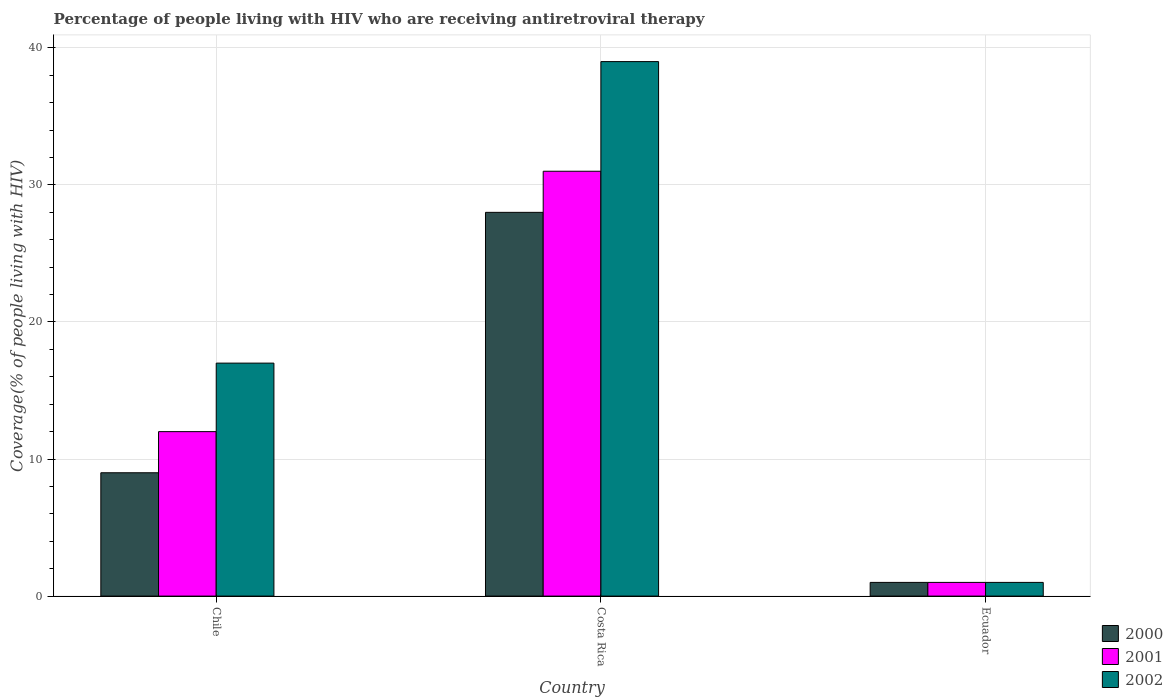How many different coloured bars are there?
Keep it short and to the point. 3. Are the number of bars on each tick of the X-axis equal?
Your answer should be compact. Yes. What is the label of the 3rd group of bars from the left?
Make the answer very short. Ecuador. In how many cases, is the number of bars for a given country not equal to the number of legend labels?
Provide a short and direct response. 0. Across all countries, what is the maximum percentage of the HIV infected people who are receiving antiretroviral therapy in 2000?
Ensure brevity in your answer.  28. Across all countries, what is the minimum percentage of the HIV infected people who are receiving antiretroviral therapy in 2002?
Provide a short and direct response. 1. In which country was the percentage of the HIV infected people who are receiving antiretroviral therapy in 2002 maximum?
Your response must be concise. Costa Rica. In which country was the percentage of the HIV infected people who are receiving antiretroviral therapy in 2000 minimum?
Ensure brevity in your answer.  Ecuador. What is the difference between the percentage of the HIV infected people who are receiving antiretroviral therapy in 2001 in Chile and the percentage of the HIV infected people who are receiving antiretroviral therapy in 2000 in Ecuador?
Make the answer very short. 11. What is the average percentage of the HIV infected people who are receiving antiretroviral therapy in 2000 per country?
Provide a short and direct response. 12.67. In how many countries, is the percentage of the HIV infected people who are receiving antiretroviral therapy in 2001 greater than 26 %?
Give a very brief answer. 1. What is the ratio of the percentage of the HIV infected people who are receiving antiretroviral therapy in 2000 in Chile to that in Costa Rica?
Your answer should be compact. 0.32. Is the difference between the percentage of the HIV infected people who are receiving antiretroviral therapy in 2002 in Chile and Costa Rica greater than the difference between the percentage of the HIV infected people who are receiving antiretroviral therapy in 2001 in Chile and Costa Rica?
Provide a succinct answer. No. What is the difference between the highest and the second highest percentage of the HIV infected people who are receiving antiretroviral therapy in 2001?
Give a very brief answer. -11. In how many countries, is the percentage of the HIV infected people who are receiving antiretroviral therapy in 2001 greater than the average percentage of the HIV infected people who are receiving antiretroviral therapy in 2001 taken over all countries?
Keep it short and to the point. 1. What does the 2nd bar from the right in Chile represents?
Your answer should be very brief. 2001. Does the graph contain any zero values?
Your answer should be compact. No. How many legend labels are there?
Ensure brevity in your answer.  3. How are the legend labels stacked?
Give a very brief answer. Vertical. What is the title of the graph?
Give a very brief answer. Percentage of people living with HIV who are receiving antiretroviral therapy. Does "2014" appear as one of the legend labels in the graph?
Your answer should be very brief. No. What is the label or title of the Y-axis?
Offer a very short reply. Coverage(% of people living with HIV). What is the Coverage(% of people living with HIV) of 2002 in Chile?
Your answer should be very brief. 17. What is the Coverage(% of people living with HIV) of 2000 in Costa Rica?
Offer a terse response. 28. What is the Coverage(% of people living with HIV) of 2000 in Ecuador?
Make the answer very short. 1. Across all countries, what is the minimum Coverage(% of people living with HIV) in 2001?
Make the answer very short. 1. Across all countries, what is the minimum Coverage(% of people living with HIV) in 2002?
Make the answer very short. 1. What is the total Coverage(% of people living with HIV) in 2000 in the graph?
Give a very brief answer. 38. What is the total Coverage(% of people living with HIV) of 2001 in the graph?
Ensure brevity in your answer.  44. What is the total Coverage(% of people living with HIV) in 2002 in the graph?
Offer a very short reply. 57. What is the difference between the Coverage(% of people living with HIV) in 2000 in Chile and that in Costa Rica?
Offer a very short reply. -19. What is the difference between the Coverage(% of people living with HIV) in 2001 in Chile and that in Costa Rica?
Give a very brief answer. -19. What is the difference between the Coverage(% of people living with HIV) in 2002 in Chile and that in Costa Rica?
Ensure brevity in your answer.  -22. What is the difference between the Coverage(% of people living with HIV) in 2000 in Chile and that in Ecuador?
Offer a very short reply. 8. What is the difference between the Coverage(% of people living with HIV) of 2002 in Chile and that in Ecuador?
Offer a terse response. 16. What is the difference between the Coverage(% of people living with HIV) in 2000 in Costa Rica and that in Ecuador?
Make the answer very short. 27. What is the difference between the Coverage(% of people living with HIV) in 2000 in Chile and the Coverage(% of people living with HIV) in 2001 in Ecuador?
Ensure brevity in your answer.  8. What is the difference between the Coverage(% of people living with HIV) in 2001 in Chile and the Coverage(% of people living with HIV) in 2002 in Ecuador?
Make the answer very short. 11. What is the difference between the Coverage(% of people living with HIV) of 2001 in Costa Rica and the Coverage(% of people living with HIV) of 2002 in Ecuador?
Offer a very short reply. 30. What is the average Coverage(% of people living with HIV) in 2000 per country?
Keep it short and to the point. 12.67. What is the average Coverage(% of people living with HIV) of 2001 per country?
Offer a very short reply. 14.67. What is the difference between the Coverage(% of people living with HIV) of 2000 and Coverage(% of people living with HIV) of 2001 in Chile?
Your answer should be very brief. -3. What is the difference between the Coverage(% of people living with HIV) in 2001 and Coverage(% of people living with HIV) in 2002 in Chile?
Give a very brief answer. -5. What is the difference between the Coverage(% of people living with HIV) in 2001 and Coverage(% of people living with HIV) in 2002 in Costa Rica?
Make the answer very short. -8. What is the difference between the Coverage(% of people living with HIV) of 2000 and Coverage(% of people living with HIV) of 2001 in Ecuador?
Your answer should be very brief. 0. What is the difference between the Coverage(% of people living with HIV) of 2000 and Coverage(% of people living with HIV) of 2002 in Ecuador?
Your answer should be very brief. 0. What is the difference between the Coverage(% of people living with HIV) of 2001 and Coverage(% of people living with HIV) of 2002 in Ecuador?
Ensure brevity in your answer.  0. What is the ratio of the Coverage(% of people living with HIV) of 2000 in Chile to that in Costa Rica?
Keep it short and to the point. 0.32. What is the ratio of the Coverage(% of people living with HIV) of 2001 in Chile to that in Costa Rica?
Ensure brevity in your answer.  0.39. What is the ratio of the Coverage(% of people living with HIV) in 2002 in Chile to that in Costa Rica?
Keep it short and to the point. 0.44. What is the ratio of the Coverage(% of people living with HIV) in 2002 in Chile to that in Ecuador?
Keep it short and to the point. 17. What is the ratio of the Coverage(% of people living with HIV) in 2000 in Costa Rica to that in Ecuador?
Keep it short and to the point. 28. What is the ratio of the Coverage(% of people living with HIV) in 2001 in Costa Rica to that in Ecuador?
Offer a terse response. 31. What is the ratio of the Coverage(% of people living with HIV) of 2002 in Costa Rica to that in Ecuador?
Your response must be concise. 39. What is the difference between the highest and the second highest Coverage(% of people living with HIV) in 2002?
Ensure brevity in your answer.  22. What is the difference between the highest and the lowest Coverage(% of people living with HIV) of 2001?
Your answer should be very brief. 30. 